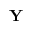<formula> <loc_0><loc_0><loc_500><loc_500>Y</formula> 